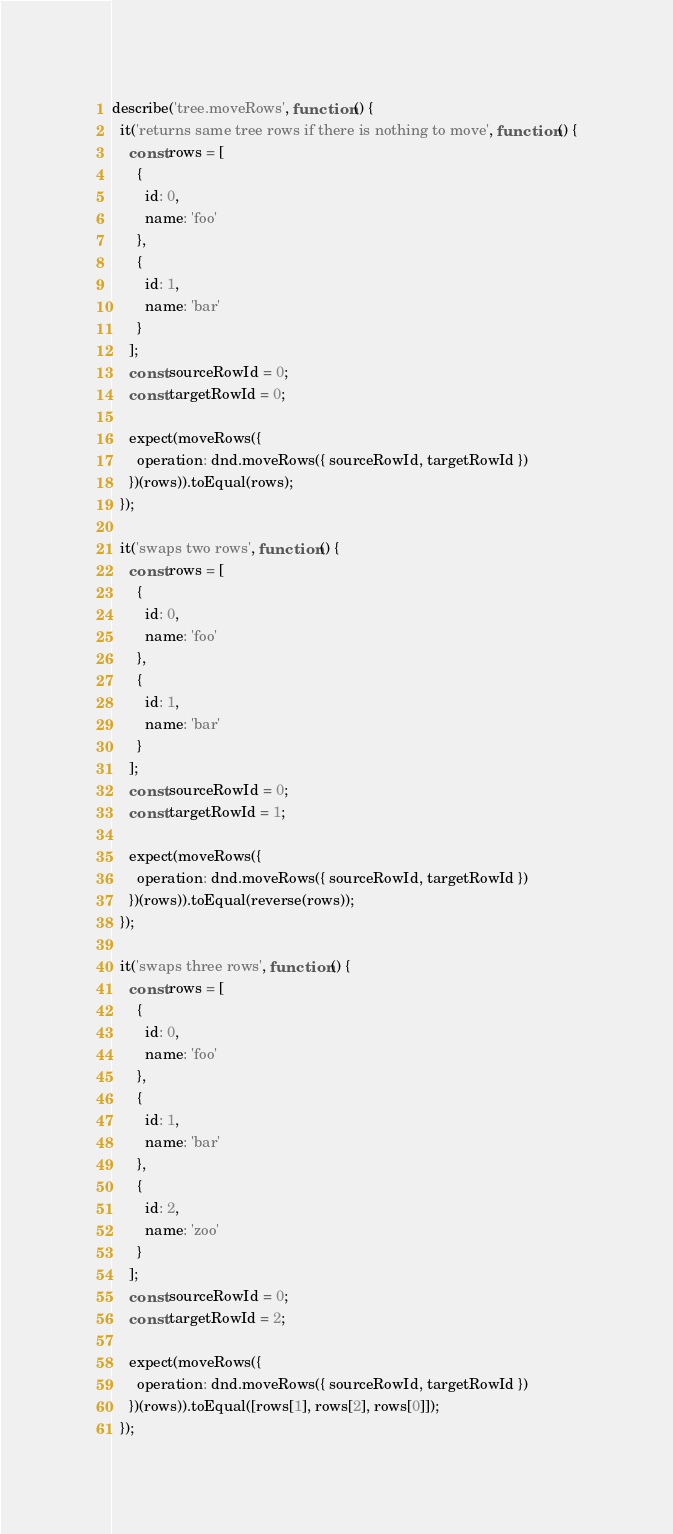<code> <loc_0><loc_0><loc_500><loc_500><_JavaScript_>describe('tree.moveRows', function () {
  it('returns same tree rows if there is nothing to move', function () {
    const rows = [
      {
        id: 0,
        name: 'foo'
      },
      {
        id: 1,
        name: 'bar'
      }
    ];
    const sourceRowId = 0;
    const targetRowId = 0;

    expect(moveRows({
      operation: dnd.moveRows({ sourceRowId, targetRowId })
    })(rows)).toEqual(rows);
  });

  it('swaps two rows', function () {
    const rows = [
      {
        id: 0,
        name: 'foo'
      },
      {
        id: 1,
        name: 'bar'
      }
    ];
    const sourceRowId = 0;
    const targetRowId = 1;

    expect(moveRows({
      operation: dnd.moveRows({ sourceRowId, targetRowId })
    })(rows)).toEqual(reverse(rows));
  });

  it('swaps three rows', function () {
    const rows = [
      {
        id: 0,
        name: 'foo'
      },
      {
        id: 1,
        name: 'bar'
      },
      {
        id: 2,
        name: 'zoo'
      }
    ];
    const sourceRowId = 0;
    const targetRowId = 2;

    expect(moveRows({
      operation: dnd.moveRows({ sourceRowId, targetRowId })
    })(rows)).toEqual([rows[1], rows[2], rows[0]]);
  });
</code> 